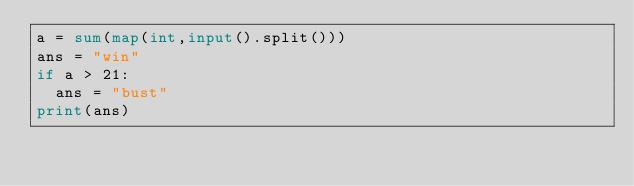Convert code to text. <code><loc_0><loc_0><loc_500><loc_500><_Python_>a = sum(map(int,input().split()))
ans = "win"
if a > 21:
  ans = "bust"
print(ans)</code> 